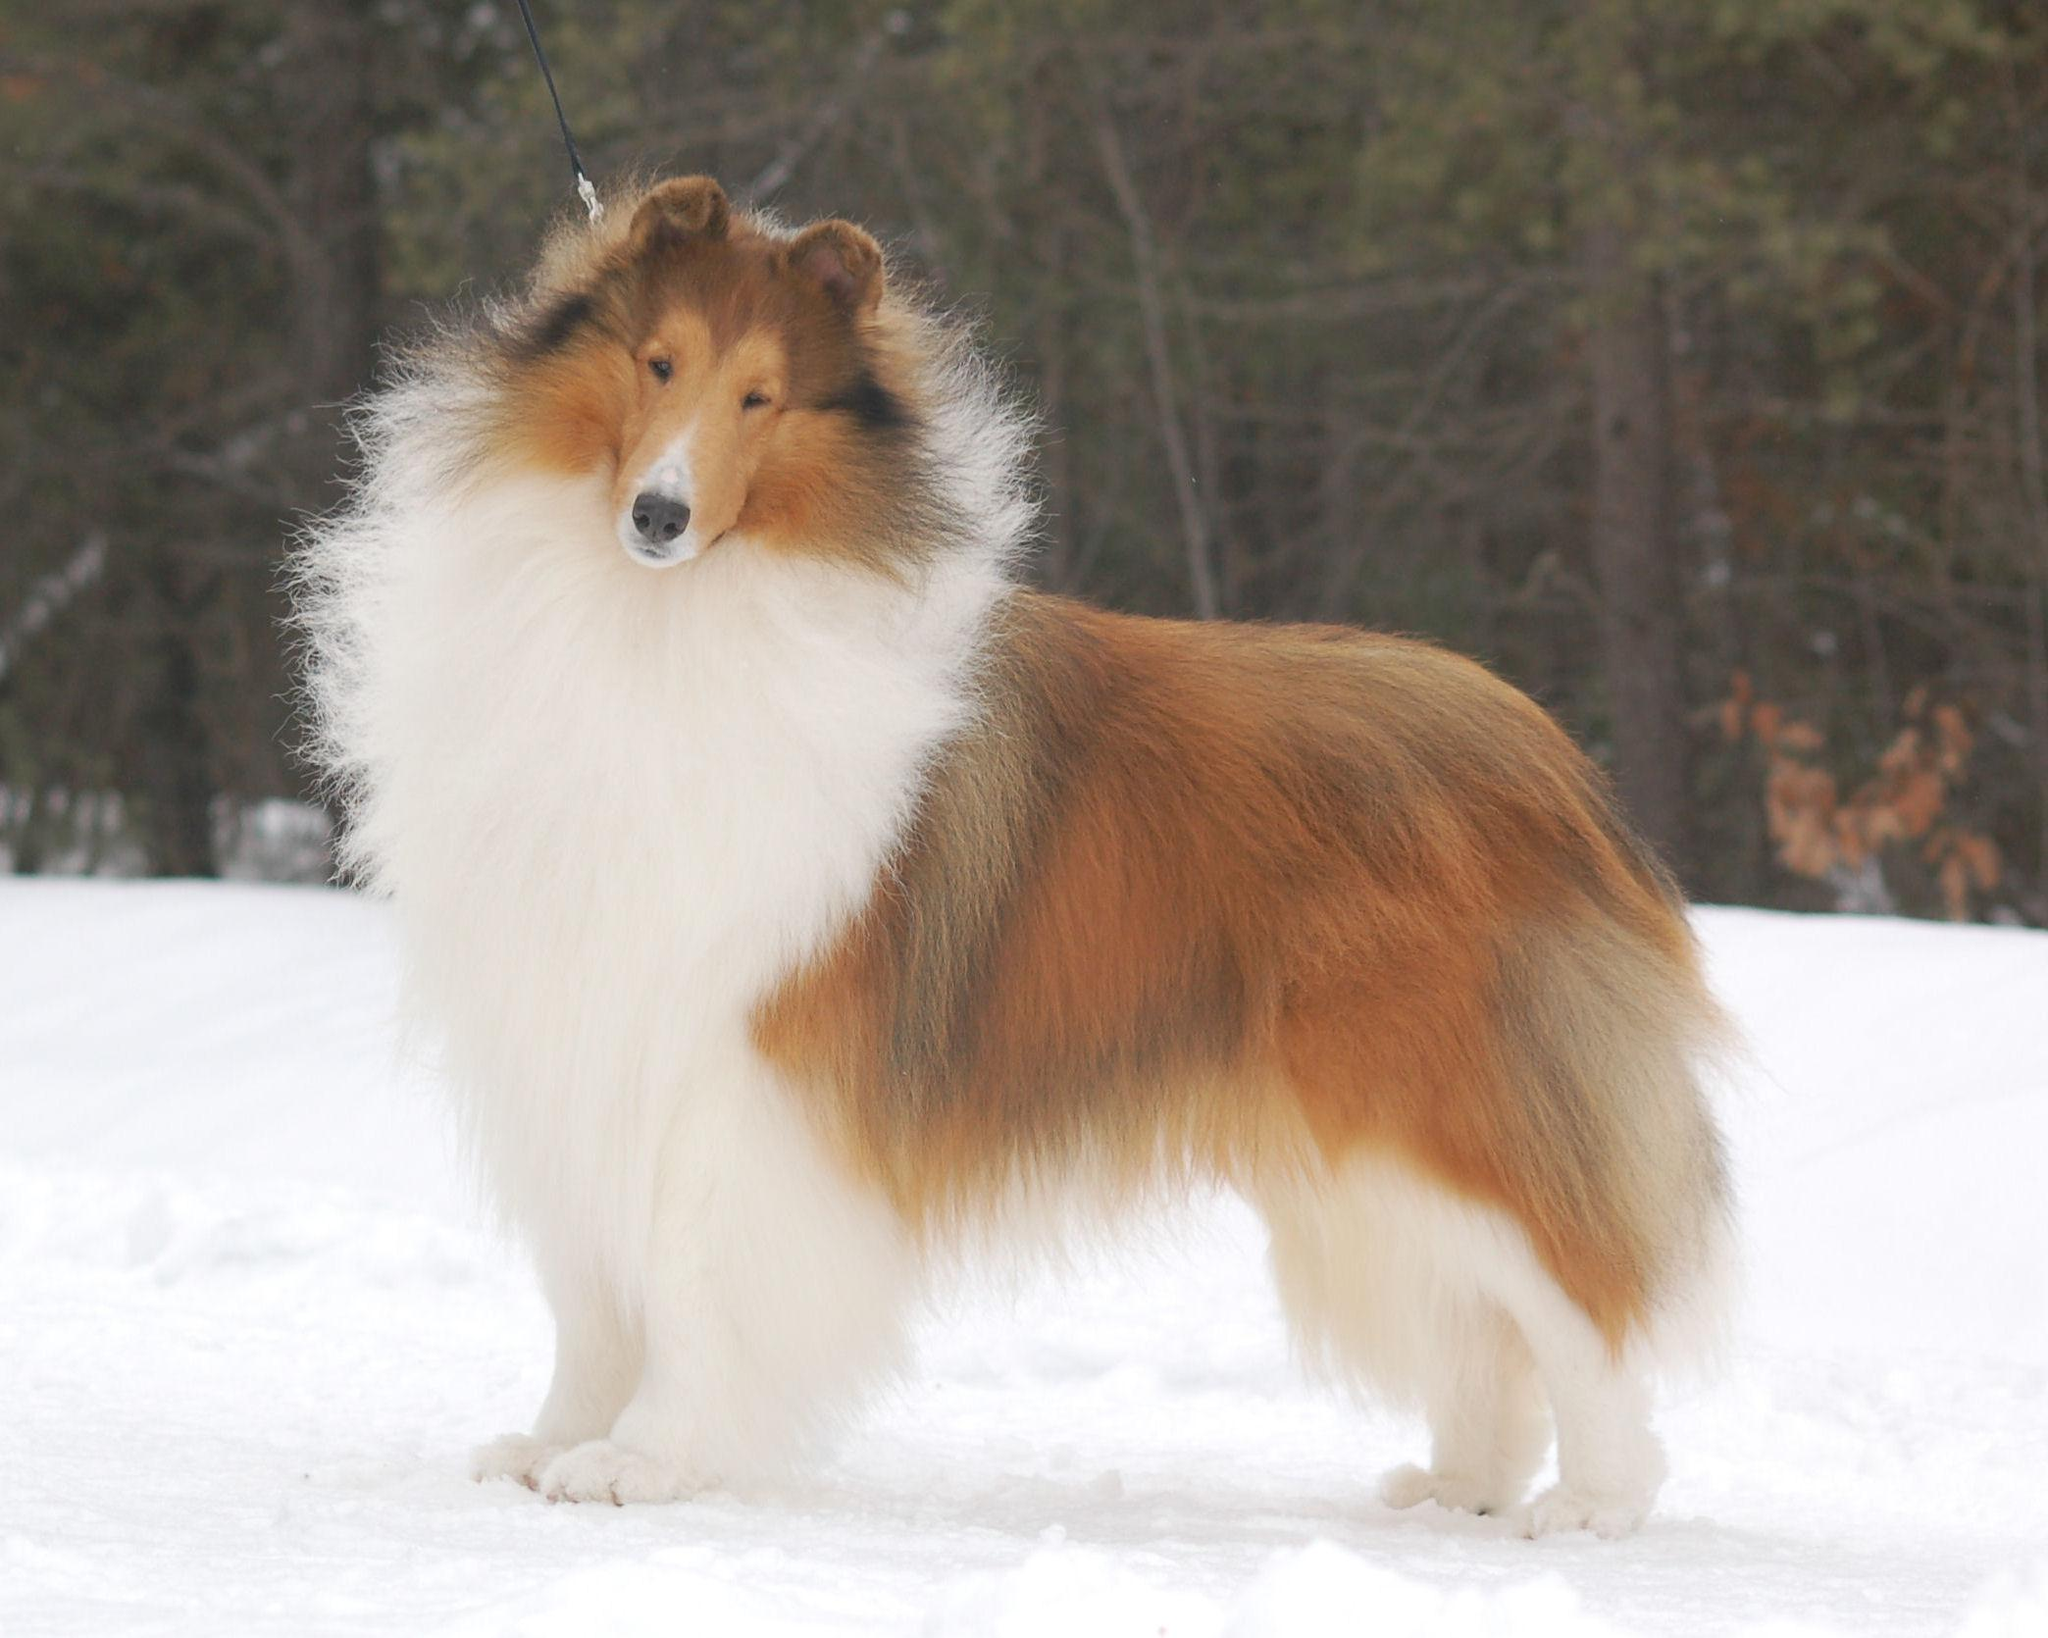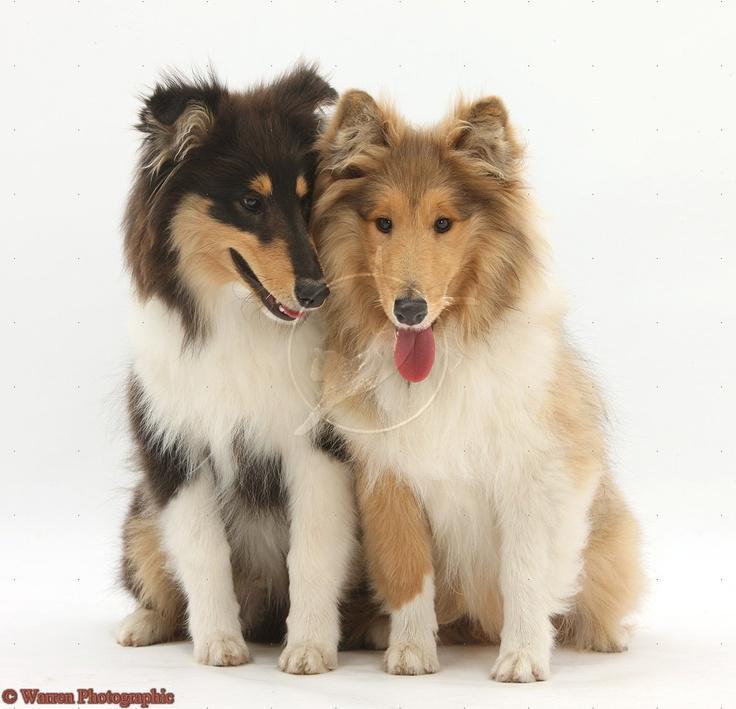The first image is the image on the left, the second image is the image on the right. Given the left and right images, does the statement "There are three dogs in total." hold true? Answer yes or no. Yes. The first image is the image on the left, the second image is the image on the right. Considering the images on both sides, is "Left and right images contain a collie pup that looks the other's twin, and the combined images show at least three of these look-alike pups." valid? Answer yes or no. No. 